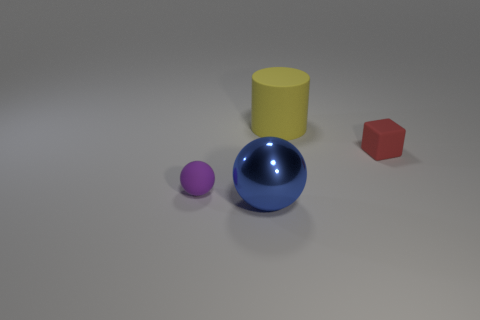What number of big objects are gray shiny cubes or red rubber blocks?
Give a very brief answer. 0. Are there fewer tiny red matte things than small green metallic objects?
Your response must be concise. No. What is the color of the matte thing that is the same shape as the metallic object?
Ensure brevity in your answer.  Purple. Is there any other thing that is the same shape as the big yellow thing?
Ensure brevity in your answer.  No. Is the number of yellow cylinders greater than the number of small objects?
Offer a terse response. No. What number of other things are there of the same material as the big sphere
Make the answer very short. 0. What is the shape of the rubber thing on the left side of the blue object that is in front of the small object right of the yellow object?
Your answer should be compact. Sphere. Are there fewer rubber blocks that are right of the big blue thing than tiny things that are in front of the yellow cylinder?
Offer a terse response. Yes. Is the big blue object made of the same material as the large yellow object behind the metal object?
Your answer should be very brief. No. There is a object that is on the left side of the large blue metallic object; is there a big yellow thing that is on the right side of it?
Ensure brevity in your answer.  Yes. 